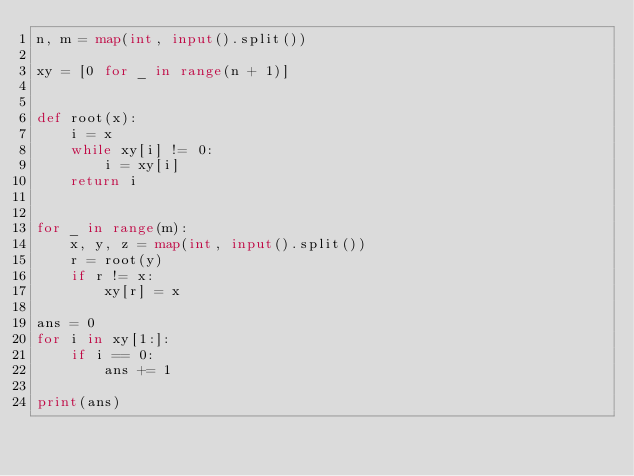Convert code to text. <code><loc_0><loc_0><loc_500><loc_500><_Python_>n, m = map(int, input().split())

xy = [0 for _ in range(n + 1)]


def root(x):
    i = x
    while xy[i] != 0:
        i = xy[i]
    return i


for _ in range(m):
    x, y, z = map(int, input().split())
    r = root(y)
    if r != x:
        xy[r] = x

ans = 0
for i in xy[1:]:
    if i == 0:
        ans += 1

print(ans)
</code> 